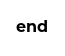Convert code to text. <code><loc_0><loc_0><loc_500><loc_500><_Ruby_>end</code> 